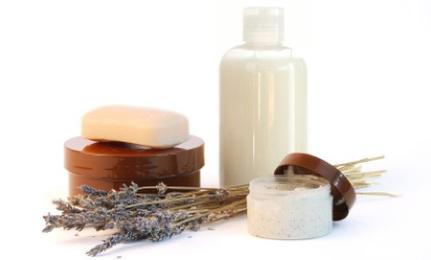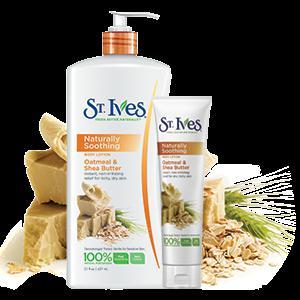The first image is the image on the left, the second image is the image on the right. Considering the images on both sides, is "Each image includes products posed with sprig-type things from nature." valid? Answer yes or no. Yes. The first image is the image on the left, the second image is the image on the right. Analyze the images presented: Is the assertion "There is a tall bottle with a pump." valid? Answer yes or no. Yes. 